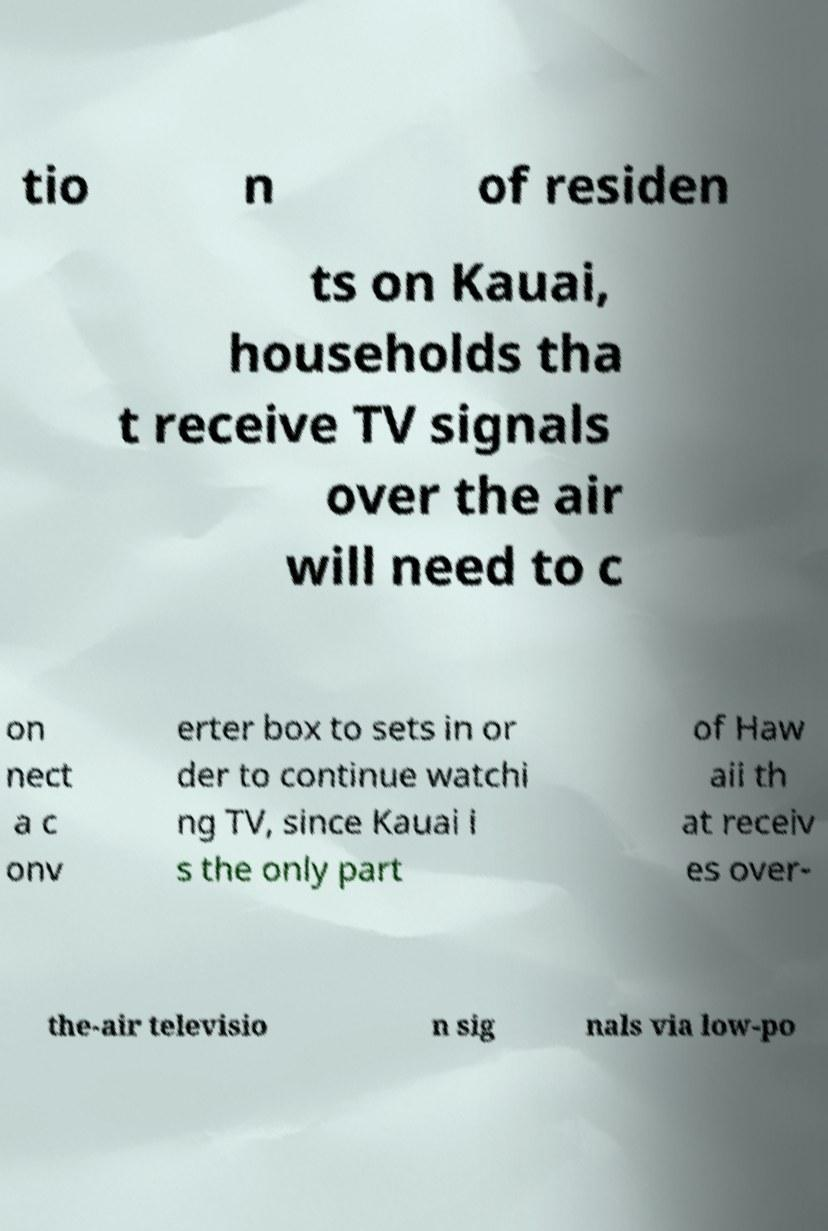Can you read and provide the text displayed in the image?This photo seems to have some interesting text. Can you extract and type it out for me? tio n of residen ts on Kauai, households tha t receive TV signals over the air will need to c on nect a c onv erter box to sets in or der to continue watchi ng TV, since Kauai i s the only part of Haw aii th at receiv es over- the-air televisio n sig nals via low-po 